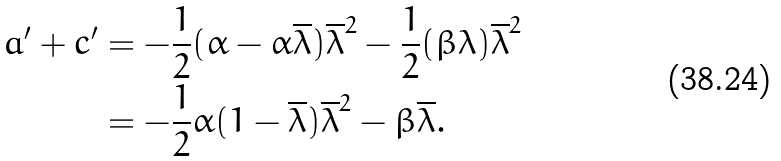<formula> <loc_0><loc_0><loc_500><loc_500>a ^ { \prime } + c ^ { \prime } & = - \frac { 1 } { 2 } ( \alpha - \alpha \overline { \lambda } ) \overline { \lambda } ^ { 2 } - \frac { 1 } { 2 } ( \beta \lambda ) \overline { \lambda } ^ { 2 } \\ & = - \frac { 1 } { 2 } \alpha ( 1 - \overline { \lambda } ) \overline { \lambda } ^ { 2 } - \beta \overline { \lambda } .</formula> 